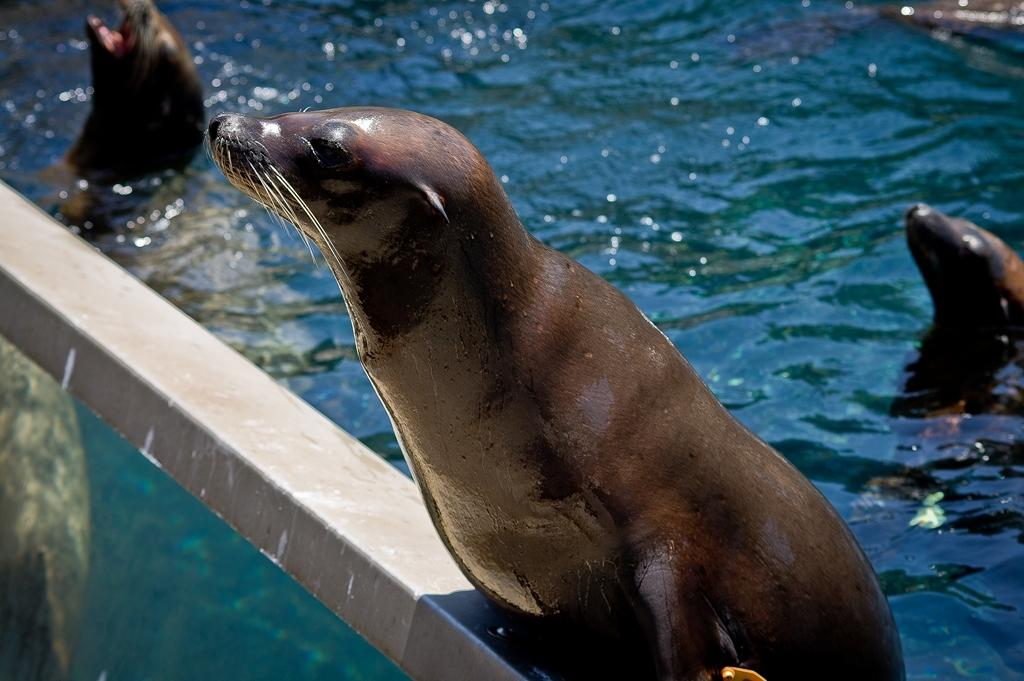What animal is on the metal rod in the image? There is a sea lion on a metal rod in the image. How many sea lions are visible in the image? There are three sea lions in total, with two in the water and one on the metal rod. Reasoning: Let's think step by step, in order to produce the conversation. We start by identifying the main subject in the image, which is the sea lion on the metal rod. Then, we expand the conversation to include the other sea lions in the water. Each question is designed to elicit a specific detail about the image that is known from the provided facts. Absurd Question/Answer: What type of star can be seen teaching the sea lions in the image? There is no star or teaching activity present in the image; it features sea lions on a metal rod and in the water. 